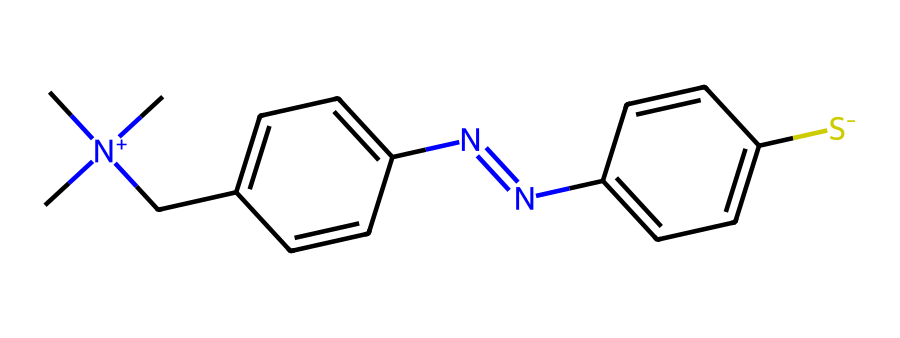What is the overall charge of this ionic liquid? The structure contains a positively charged nitrogen atom ([N+]), indicating that the compound carries a positive charge. Conversely, it also contains a negatively charged sulfur atom ([S-]). Adding these charges gives an overall neutral charge.
Answer: neutral How many rings are present in this chemical structure? By examining the structure, there are two distinct ring systems present; one is a five-membered ring containing nitrogen, and the other is a six-membered aromatic ring. Totaling them gives two rings.
Answer: two Which atoms in the structure signify the presence of functional groups? The presence of nitrogen and sulfur atoms in the structure signifies the existence of functional groups, specifically a quaternary ammonium group (due to the nitrogen) and a thiazole ring (due to the sulfur).
Answer: nitrogen and sulfur What type of bonding primarily accounts for the liquid state of ionic liquids? Ionic liquids are characterized by ionic bonding between the charged ions. This type of bond results in low melting points and maintains the liquid state at room temperature.
Answer: ionic bonding What specific feature might contribute to color-changing properties in this ionic liquid? The conjugated double bonds in the aromatic rings facilitate electronic transitions, which is a key feature that allows color changes when environmental conditions like temperature or pH are altered.
Answer: conjugated double bonds 